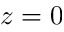Convert formula to latex. <formula><loc_0><loc_0><loc_500><loc_500>z = 0</formula> 